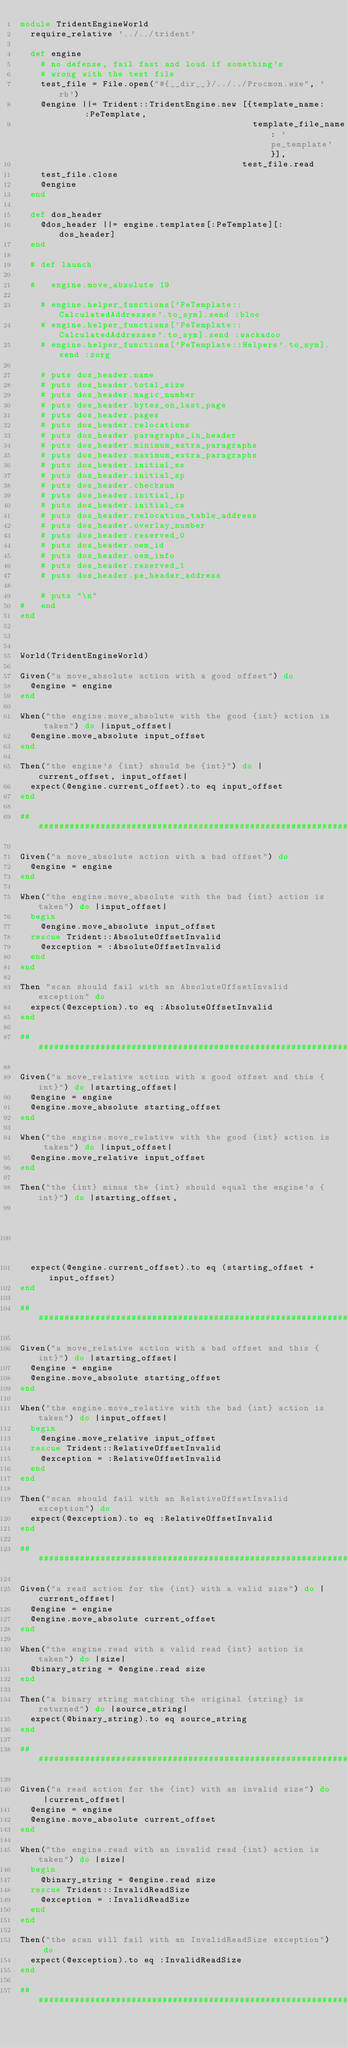<code> <loc_0><loc_0><loc_500><loc_500><_Ruby_>module TridentEngineWorld
  require_relative '../../trident'

  def engine
    # no defense, fail fast and loud if something's
    # wrong with the test file
    test_file = File.open("#{__dir__}/../../Procmon.exe", 'rb')
    @engine ||= Trident::TridentEngine.new [{template_name:      :PeTemplate,
                                             template_file_name: 'pe_template'}],
                                           test_file.read
    test_file.close
    @engine
  end
  
  def dos_header
    @dos_header ||= engine.templates[:PeTemplate][:dos_header]
  end

  # def launch

  #   engine.move_absolute 19
    
    # engine.helper_functions['PeTemplate::CalculatedAddresses'.to_sym].send :bloo
    # engine.helper_functions['PeTemplate::CalculatedAddresses'.to_sym].send :wackadoo
    # engine.helper_functions['PeTemplate::Helpers'.to_sym].send :zorg

    # puts dos_header.name
    # puts dos_header.total_size
    # puts dos_header.magic_number
    # puts dos_header.bytes_on_last_page
    # puts dos_header.pages
    # puts dos_header.relocations
    # puts dos_header.paragraphs_in_header
    # puts dos_header.minimum_extra_paragraphs
    # puts dos_header.maximum_extra_paragraphs
    # puts dos_header.initial_ss
    # puts dos_header.initial_sp
    # puts dos_header.checksum
    # puts dos_header.initial_ip
    # puts dos_header.initial_cs
    # puts dos_header.relocation_table_address
    # puts dos_header.overlay_number
    # puts dos_header.reserved_0
    # puts dos_header.oem_id
    # puts dos_header.oem_info
    # puts dos_header.reserved_1
    # puts dos_header.pe_header_address

    # puts "\n"
#   end
end



World(TridentEngineWorld)

Given("a move_absolute action with a good offset") do
  @engine = engine
end

When("the engine.move_absolute with the good {int} action is taken") do |input_offset|
  @engine.move_absolute input_offset
end

Then("the engine's {int} should be {int}") do |current_offset, input_offset|
  expect(@engine.current_offset).to eq input_offset
end

############################################################################

Given("a move_absolute action with a bad offset") do
  @engine = engine
end

When("the engine.move_absolute with the bad {int} action is taken") do |input_offset|
  begin
    @engine.move_absolute input_offset
  rescue Trident::AbsoluteOffsetInvalid
    @exception = :AbsoluteOffsetInvalid
  end
end

Then "scan should fail with an AbsoluteOffsetInvalid exception" do
  expect(@exception).to eq :AbsoluteOffsetInvalid
end

############################################################################

Given("a move_relative action with a good offset and this {int}") do |starting_offset|
  @engine = engine
  @engine.move_absolute starting_offset
end

When("the engine.move_relative with the good {int} action is taken") do |input_offset|
  @engine.move_relative input_offset
end

Then("the {int} minus the {int} should equal the engine's {int}") do |starting_offset,
                                                                      input_offset,
                                                                      current_offset|
  expect(@engine.current_offset).to eq (starting_offset + input_offset)
end

############################################################################

Given("a move_relative action with a bad offset and this {int}") do |starting_offset|
  @engine = engine
  @engine.move_absolute starting_offset
end

When("the engine.move_relative with the bad {int} action is taken") do |input_offset|
  begin
    @engine.move_relative input_offset
  rescue Trident::RelativeOffsetInvalid
    @exception = :RelativeOffsetInvalid
  end
end

Then("scan should fail with an RelativeOffsetInvalid exception") do
  expect(@exception).to eq :RelativeOffsetInvalid
end

############################################################################

Given("a read action for the {int} with a valid size") do |current_offset|
  @engine = engine
  @engine.move_absolute current_offset
end

When("the engine.read with a valid read {int} action is taken") do |size|
  @binary_string = @engine.read size
end

Then("a binary string matching the original {string} is returned") do |source_string|
  expect(@binary_string).to eq source_string
end

############################################################################

Given("a read action for the {int} with an invalid size") do |current_offset|
  @engine = engine
  @engine.move_absolute current_offset
end

When("the engine.read with an invalid read {int} action is taken") do |size|
  begin
    @binary_string = @engine.read size
  rescue Trident::InvalidReadSize
    @exception = :InvalidReadSize
  end
end

Then("the scan will fail with an InvalidReadSize exception") do
  expect(@exception).to eq :InvalidReadSize
end

############################################################################
</code> 